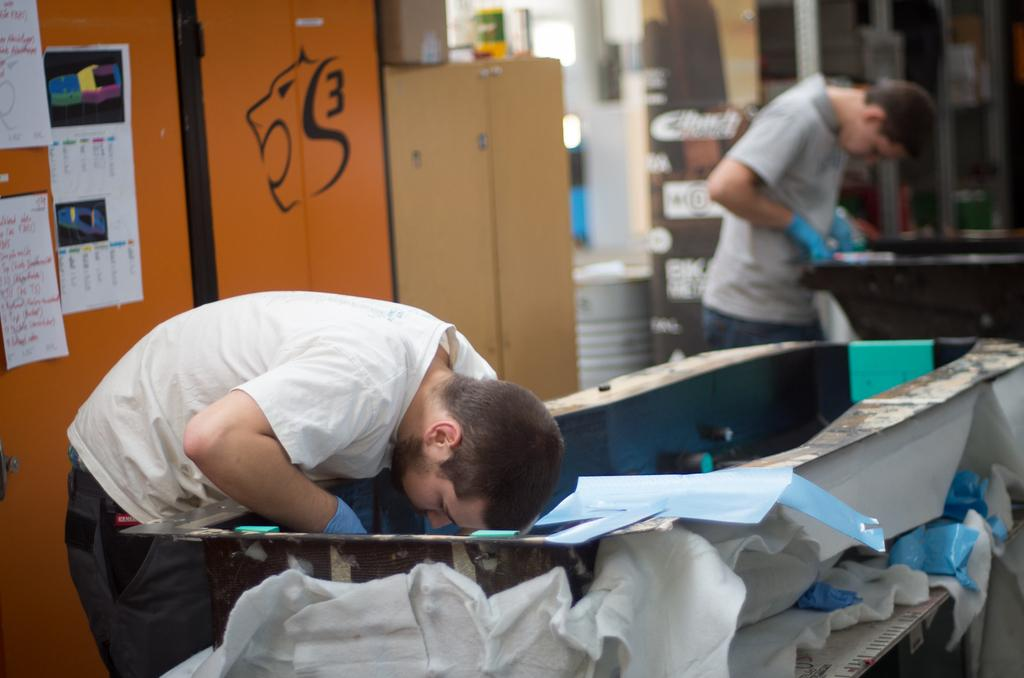What are the two people in the image doing? The two people in the image are standing and doing some work. What can be seen on the tables in the image? There are objects on the tables in the image. What is visible in the background of the image? There are cupboards in the background, and papers are stuck to a door. How many houses are visible in the image? There are no houses visible in the image. What type of light is being used by the people in the image? The provided facts do not mention any light source, so it cannot be determined from the image. 